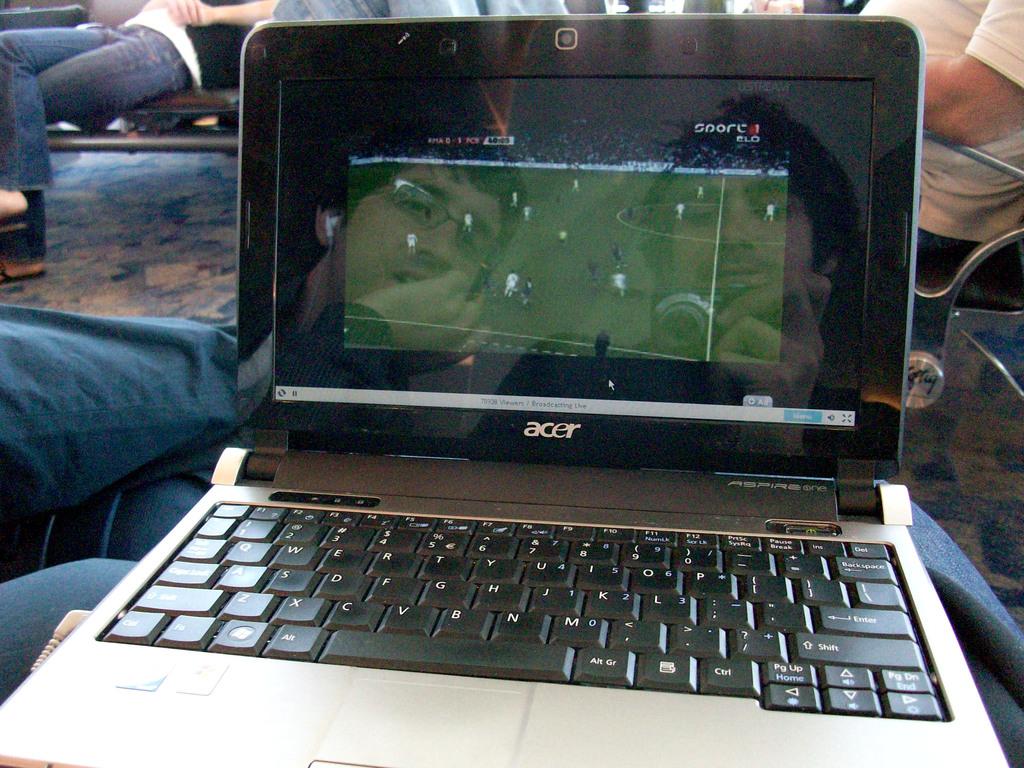What brand is this laptop?
Your answer should be compact. Acer. 